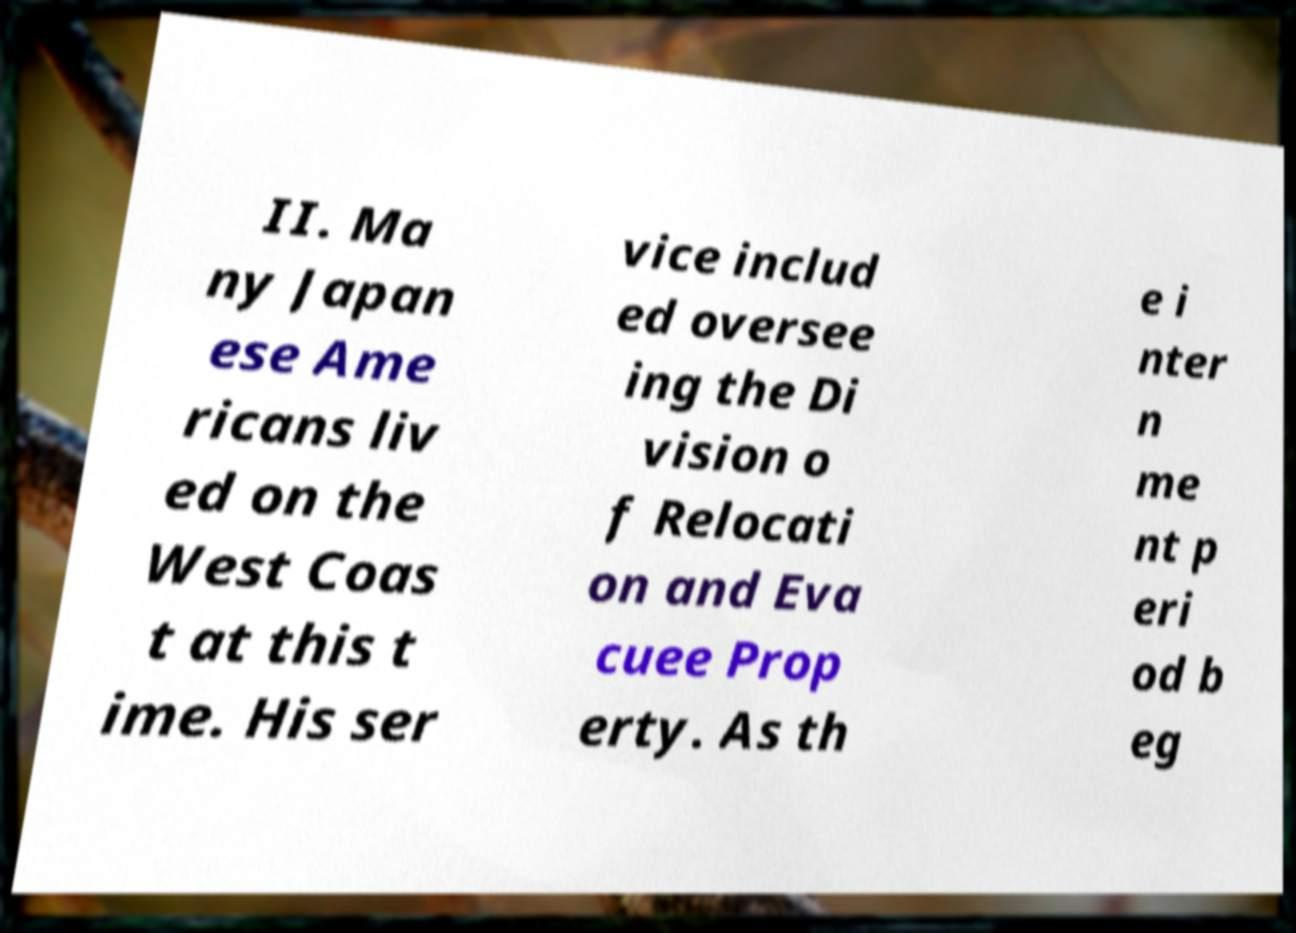Could you assist in decoding the text presented in this image and type it out clearly? II. Ma ny Japan ese Ame ricans liv ed on the West Coas t at this t ime. His ser vice includ ed oversee ing the Di vision o f Relocati on and Eva cuee Prop erty. As th e i nter n me nt p eri od b eg 